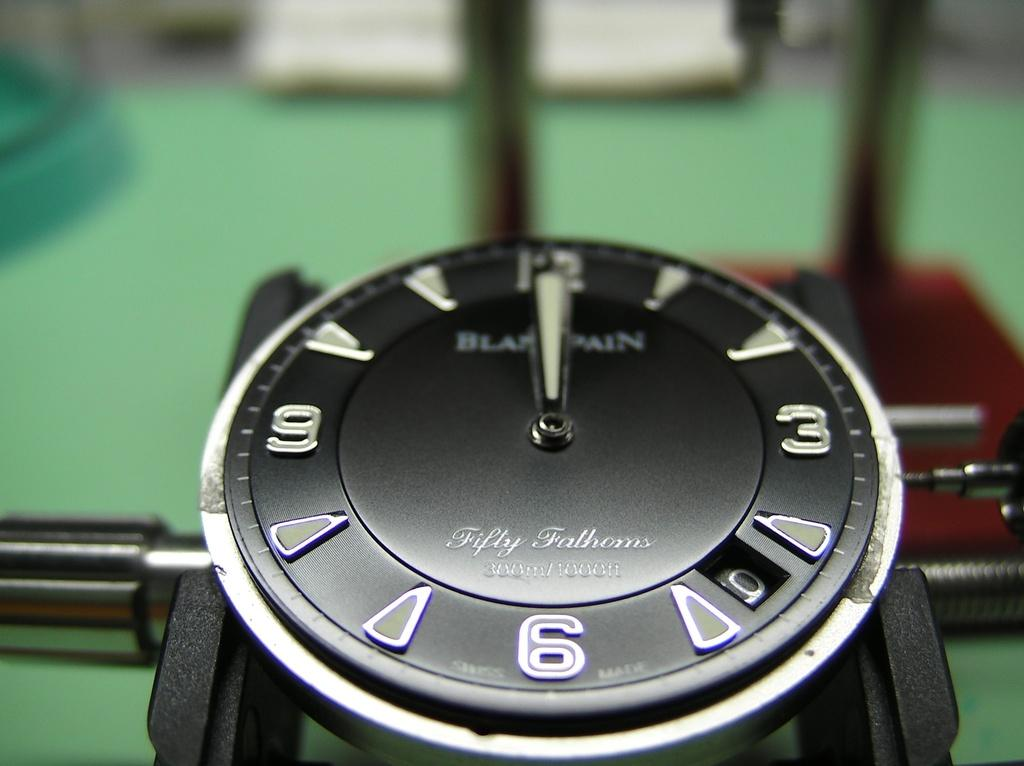<image>
Relay a brief, clear account of the picture shown. A watch face that is black with numbers that are white wiht words that say Blam pain 